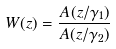Convert formula to latex. <formula><loc_0><loc_0><loc_500><loc_500>W ( z ) = \frac { A ( z / \gamma _ { 1 } ) } { A ( z / \gamma _ { 2 } ) }</formula> 